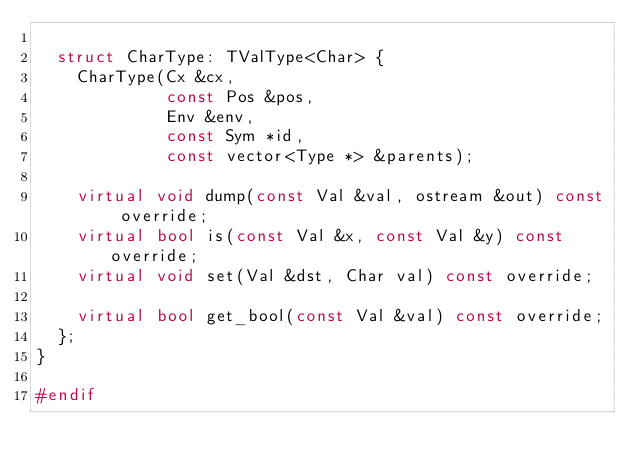<code> <loc_0><loc_0><loc_500><loc_500><_C++_>
  struct CharType: TValType<Char> {
    CharType(Cx &cx,
             const Pos &pos,
             Env &env,
             const Sym *id,
             const vector<Type *> &parents);
    
    virtual void dump(const Val &val, ostream &out) const override;
    virtual bool is(const Val &x, const Val &y) const override;
    virtual void set(Val &dst, Char val) const override;

    virtual bool get_bool(const Val &val) const override;
  };
}

#endif
</code> 